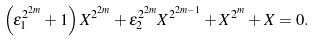Convert formula to latex. <formula><loc_0><loc_0><loc_500><loc_500>\left ( \epsilon _ { 1 } ^ { 2 ^ { 2 m } } + 1 \right ) X ^ { 2 ^ { 2 m } } + \epsilon _ { 2 } ^ { 2 ^ { 2 m } } X ^ { 2 ^ { 2 m - 1 } } + X ^ { 2 ^ { m } } + X = 0 .</formula> 